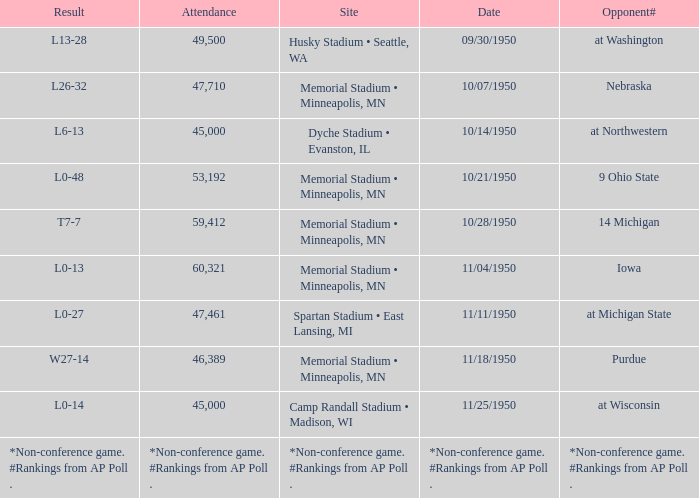What is the date when the opponent# is iowa? 11/04/1950. 